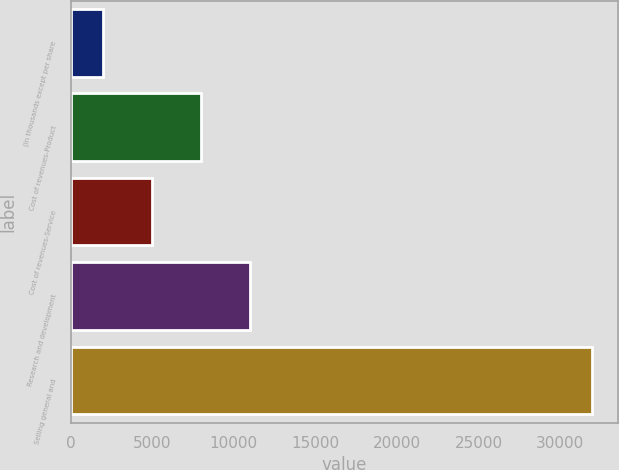<chart> <loc_0><loc_0><loc_500><loc_500><bar_chart><fcel>(In thousands except per share<fcel>Cost of revenues-Product<fcel>Cost of revenues-Service<fcel>Research and development<fcel>Selling general and<nl><fcel>2007<fcel>7999<fcel>5003<fcel>10995<fcel>31967<nl></chart> 